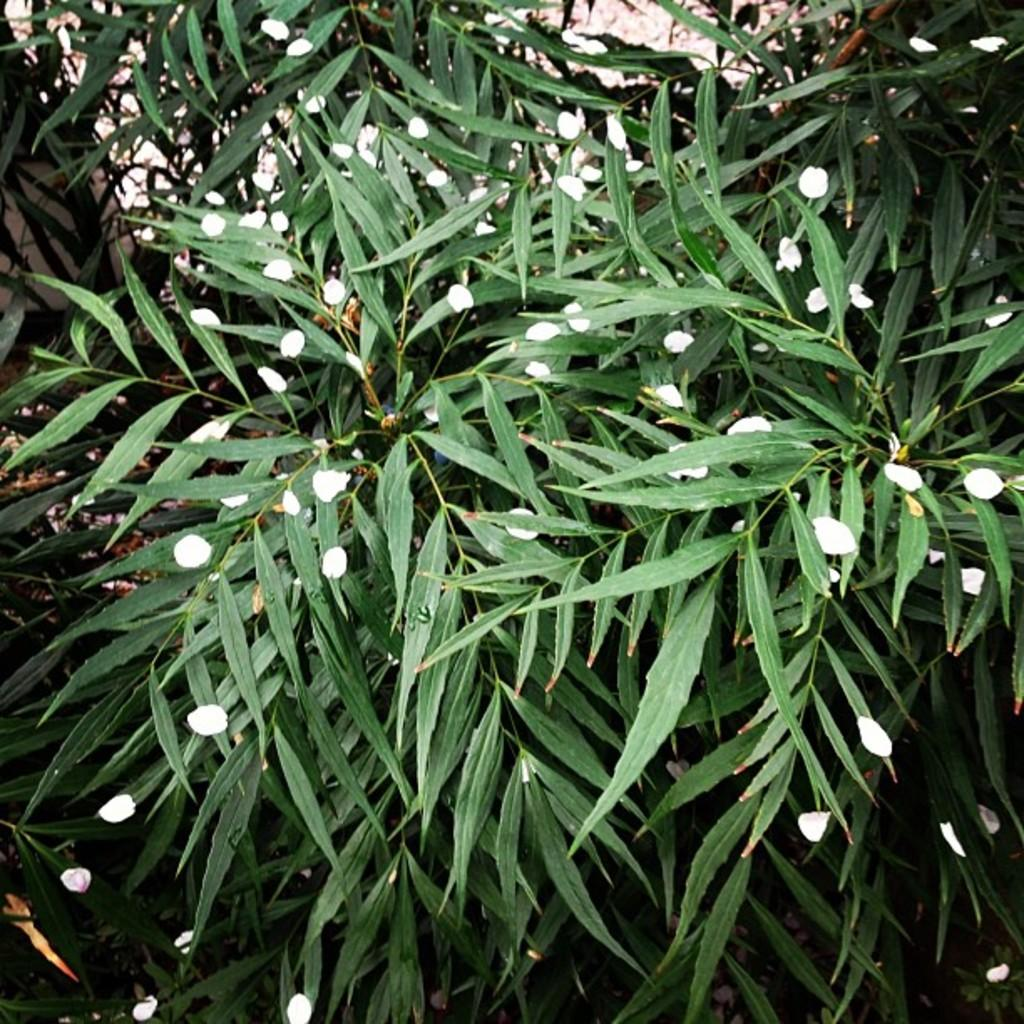What color are the trees in the image? The trees in the image are green. What color are the other objects in the image? There are white color objects in the image. Can you see a bee flying around the trees in the image? There is no bee present in the image. 